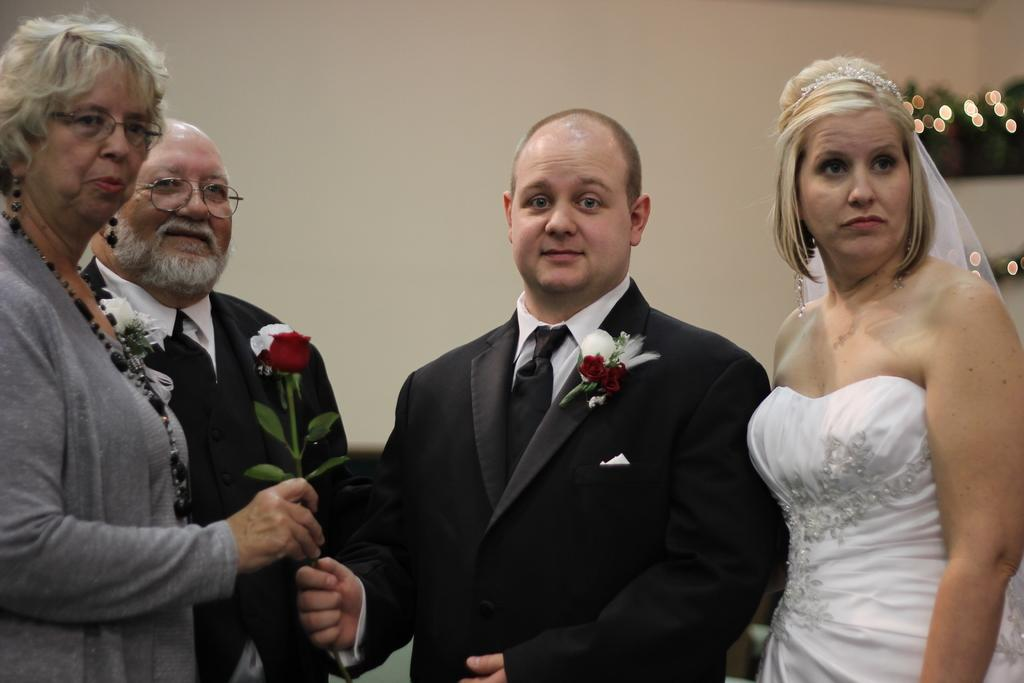What is happening in the image? There are people standing in the image. Can you describe any specific actions being performed by the people? Two persons are holding flowers in the image. What type of stranger can be seen smashing the bushes in the image? There is no stranger or smashing of bushes present in the image. 